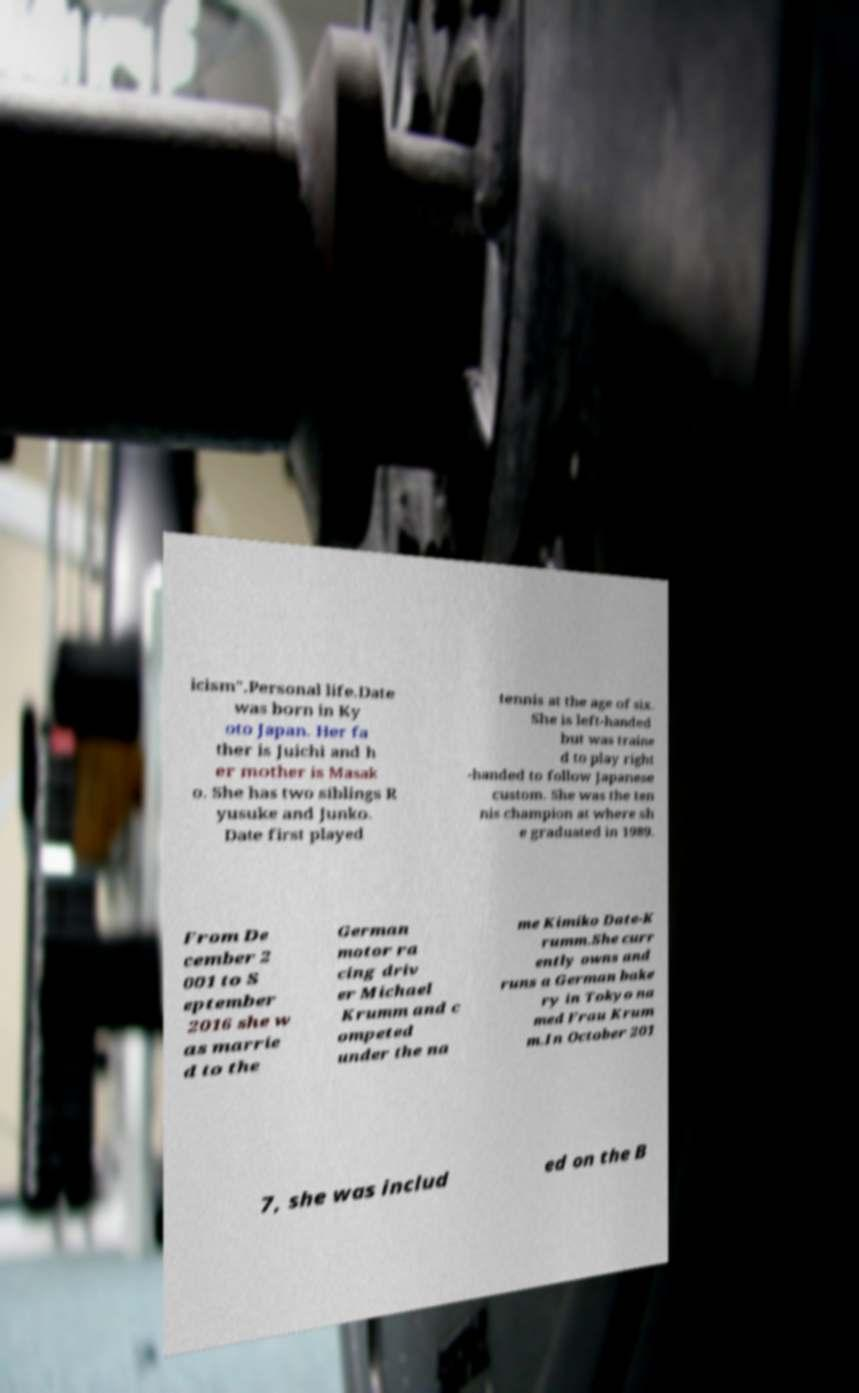Can you accurately transcribe the text from the provided image for me? icism".Personal life.Date was born in Ky oto Japan. Her fa ther is Juichi and h er mother is Masak o. She has two siblings R yusuke and Junko. Date first played tennis at the age of six. She is left-handed but was traine d to play right -handed to follow Japanese custom. She was the ten nis champion at where sh e graduated in 1989. From De cember 2 001 to S eptember 2016 she w as marrie d to the German motor ra cing driv er Michael Krumm and c ompeted under the na me Kimiko Date-K rumm.She curr ently owns and runs a German bake ry in Tokyo na med Frau Krum m.In October 201 7, she was includ ed on the B 